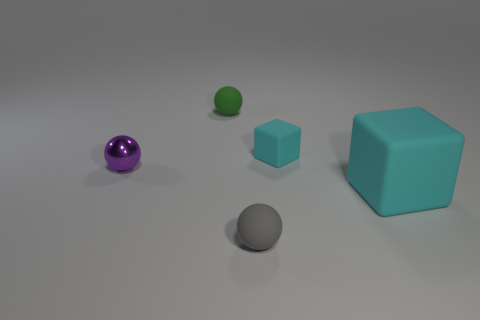There is a tiny rubber thing that is both to the left of the small cyan matte block and behind the big rubber block; what is its color?
Keep it short and to the point. Green. Does the green object have the same size as the thing on the left side of the small green sphere?
Give a very brief answer. Yes. What is the shape of the object on the left side of the green rubber sphere?
Offer a terse response. Sphere. Is there any other thing that is made of the same material as the small green sphere?
Provide a short and direct response. Yes. Is the number of tiny shiny objects that are right of the tiny gray thing greater than the number of large blocks?
Your answer should be very brief. No. There is a tiny rubber ball behind the cyan object that is in front of the tiny metallic object; what number of rubber objects are right of it?
Your answer should be compact. 3. Does the cyan rubber object that is to the right of the tiny cyan thing have the same size as the matte object to the left of the gray thing?
Offer a very short reply. No. What is the material of the tiny thing that is on the right side of the rubber sphere that is in front of the purple shiny sphere?
Provide a succinct answer. Rubber. What number of objects are either tiny objects right of the small green ball or large brown spheres?
Provide a short and direct response. 2. Are there the same number of matte cubes to the right of the big matte thing and green balls that are left of the small green rubber sphere?
Ensure brevity in your answer.  Yes. 